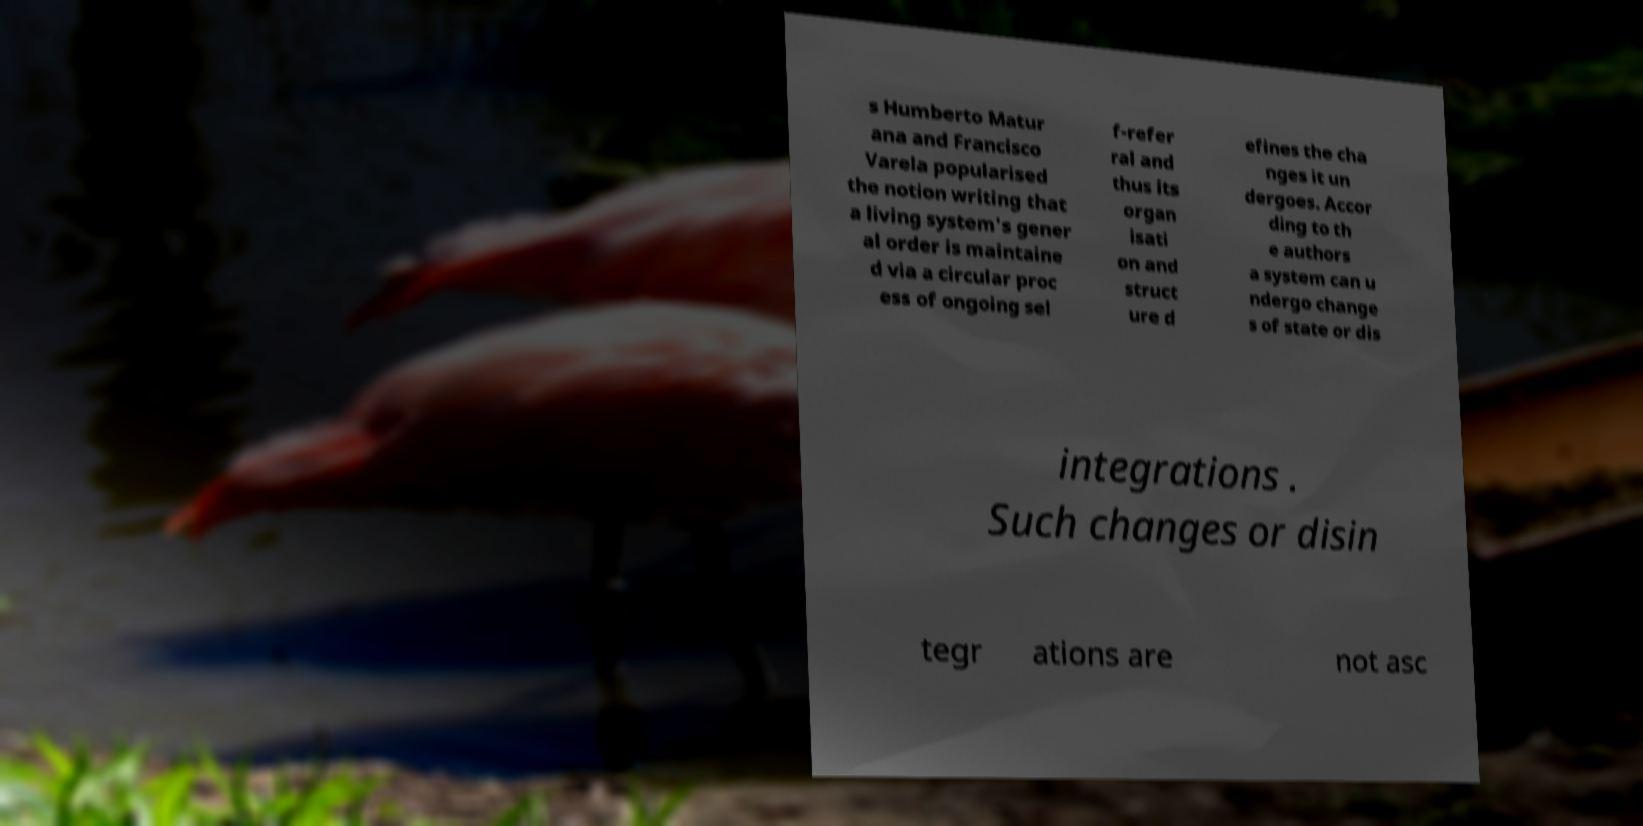For documentation purposes, I need the text within this image transcribed. Could you provide that? s Humberto Matur ana and Francisco Varela popularised the notion writing that a living system's gener al order is maintaine d via a circular proc ess of ongoing sel f-refer ral and thus its organ isati on and struct ure d efines the cha nges it un dergoes. Accor ding to th e authors a system can u ndergo change s of state or dis integrations . Such changes or disin tegr ations are not asc 